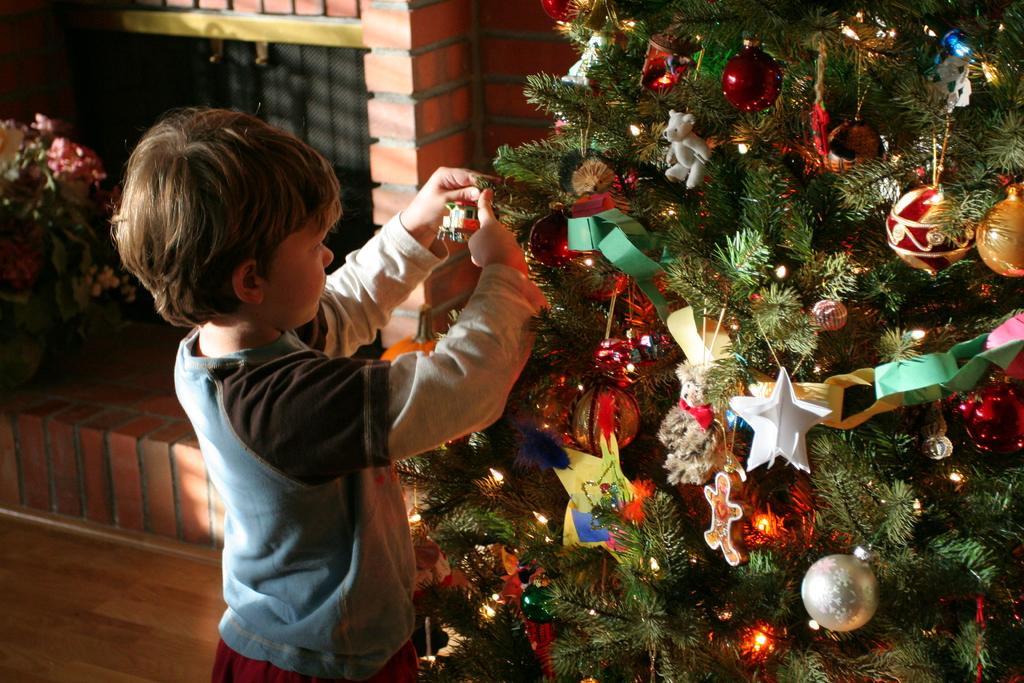Describe this image in one or two sentences. In this image I can see on the right side there is a Christmas tree decorated with lights and other things, on the left side a boy is standing and touching the tree, he is wearing a t-shirt, at the back side there is the brick wall. 